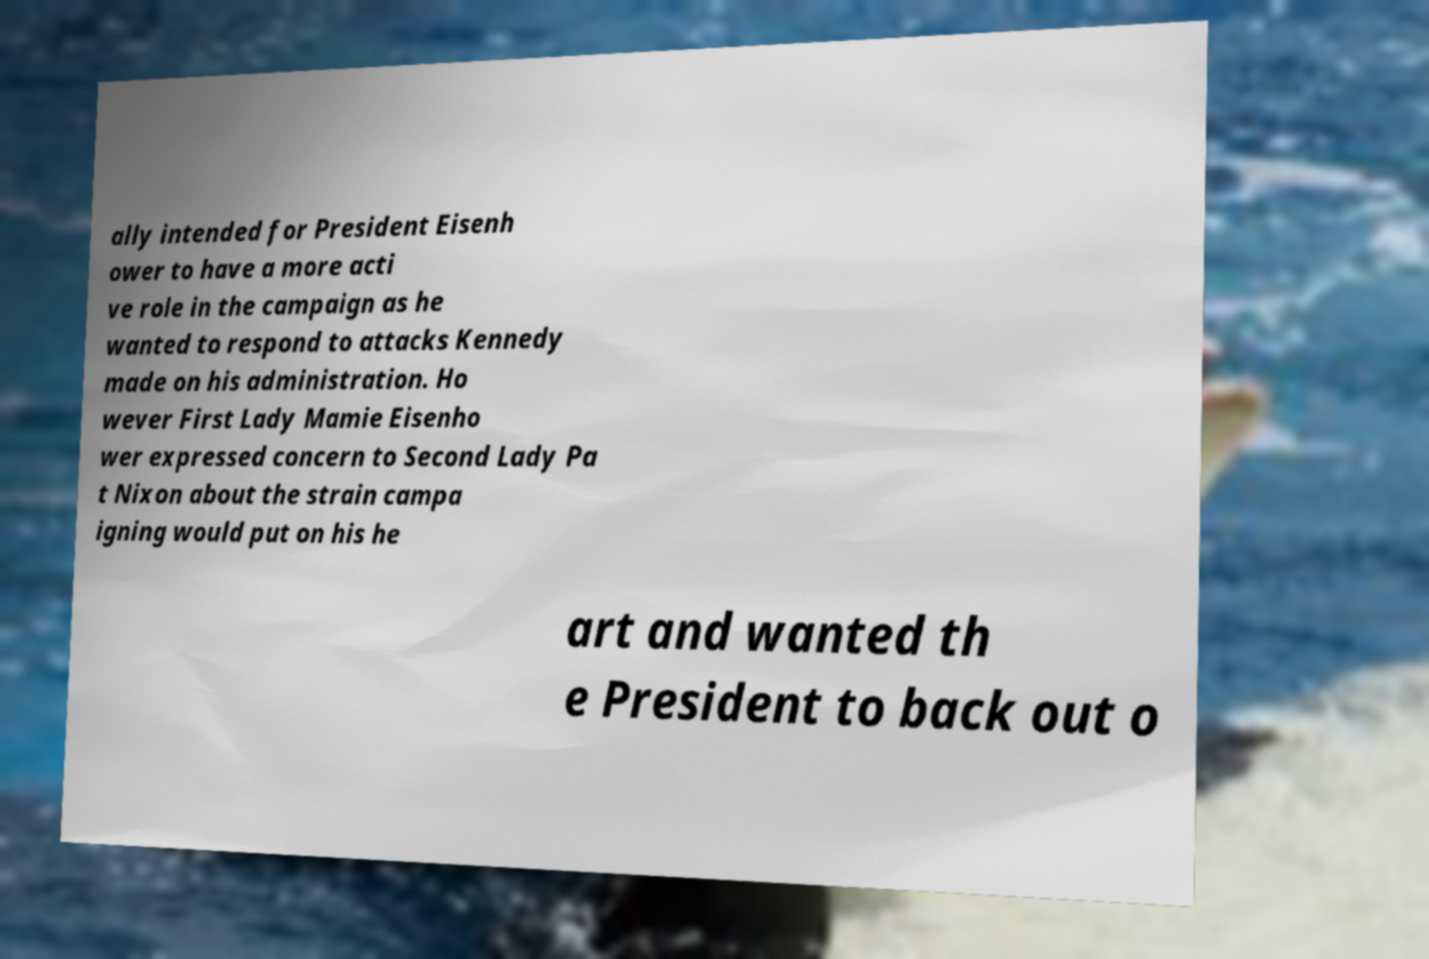Could you assist in decoding the text presented in this image and type it out clearly? ally intended for President Eisenh ower to have a more acti ve role in the campaign as he wanted to respond to attacks Kennedy made on his administration. Ho wever First Lady Mamie Eisenho wer expressed concern to Second Lady Pa t Nixon about the strain campa igning would put on his he art and wanted th e President to back out o 